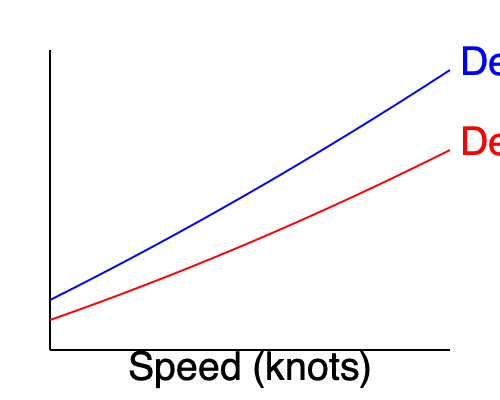As a boat captain familiar with various vessel designs in the Aegean, you're comparing two boat designs for a new tour operation. The graph shows the drag coefficient versus speed for two designs, A and B. If both boats have identical 200 hp engines with a fuel consumption rate of 0.4 liters per hp-hour, which design would be more fuel-efficient at a cruising speed of 20 knots? Assume the relationship between drag coefficient ($C_d$) and fuel consumption ($F$) is given by $F = k \cdot C_d \cdot v^3$, where $k$ is a constant and $v$ is the speed in knots. To determine which boat design is more fuel-efficient at 20 knots, we need to compare their drag coefficients at this speed and relate it to fuel consumption. Let's approach this step-by-step:

1) From the graph, we can estimate the drag coefficients at 20 knots:
   Design A: $C_{dA} \approx 0.22$
   Design B: $C_{dB} \approx 0.16$

2) The fuel consumption formula is given as:
   $F = k \cdot C_d \cdot v^3$

3) Since we're comparing the same speed (20 knots) and the constant $k$ is the same for both designs, we can compare the fuel consumption directly using the drag coefficients:

   $\frac{F_A}{F_B} = \frac{k \cdot C_{dA} \cdot 20^3}{k \cdot C_{dB} \cdot 20^3} = \frac{C_{dA}}{C_{dB}} = \frac{0.22}{0.16} \approx 1.375$

4) This means that at 20 knots, Design A consumes about 37.5% more fuel than Design B.

5) Therefore, Design B is more fuel-efficient at the cruising speed of 20 knots.

It's important to note that while the engine specifications are given, they are not directly used in this comparison. The drag coefficient is the determining factor for fuel efficiency at a given speed, assuming all other factors are equal.
Answer: Design B 